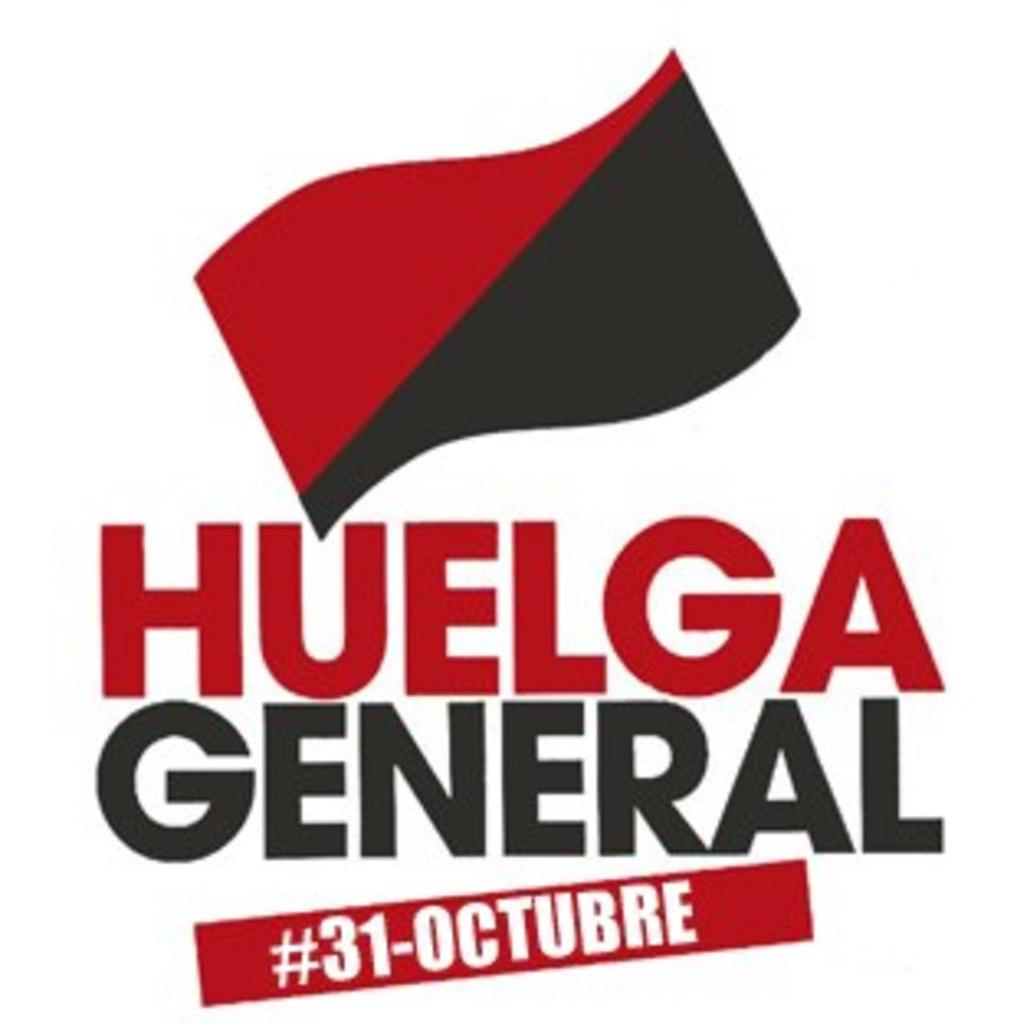Provide a one-sentence caption for the provided image. picture of an advertisement showing the date oct.31. 